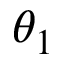Convert formula to latex. <formula><loc_0><loc_0><loc_500><loc_500>\theta _ { 1 }</formula> 